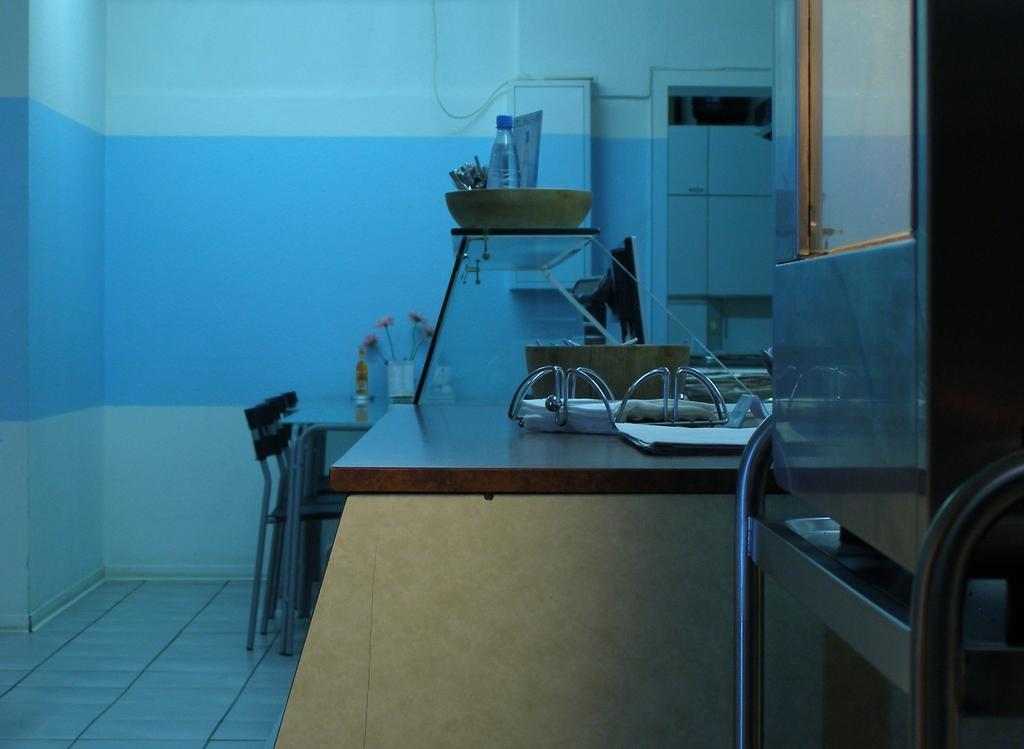What is on the table in the image? There are objects on the table in the image. What type of furniture is present in the image? There are chairs in the image. What can be seen in the background of the image? There is a wall visible in the background of the image. What day of the week is it in the image? The day of the week cannot be determined from the image, as it does not provide any information about the date or time. Is there a roof visible in the image? No, there is no roof visible in the image; only a wall is visible in the background. 